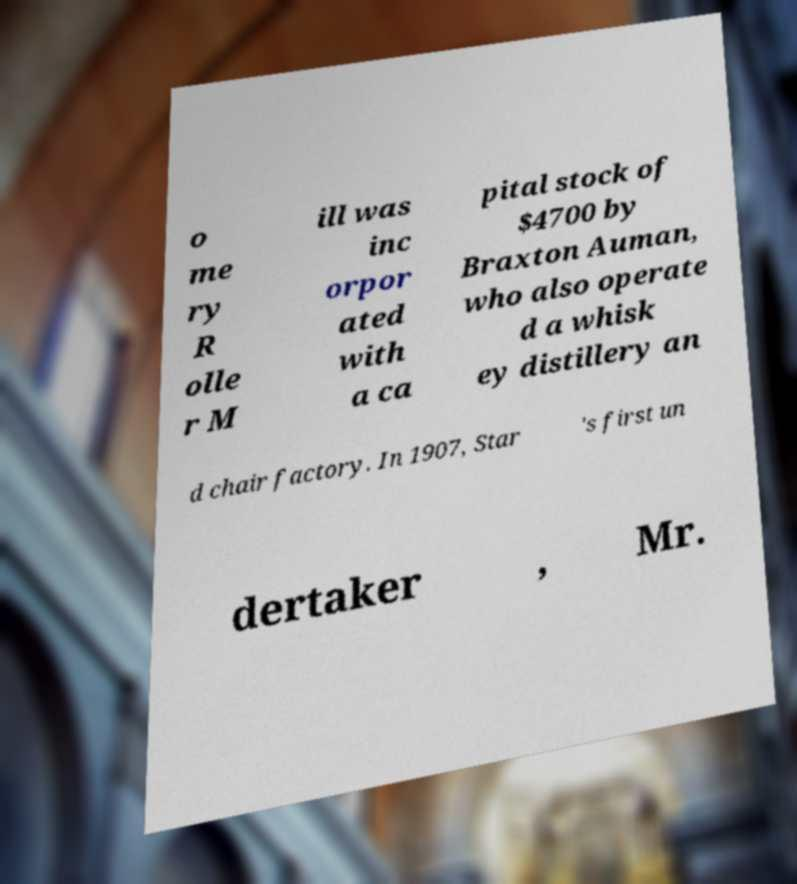Can you accurately transcribe the text from the provided image for me? o me ry R olle r M ill was inc orpor ated with a ca pital stock of $4700 by Braxton Auman, who also operate d a whisk ey distillery an d chair factory. In 1907, Star 's first un dertaker , Mr. 